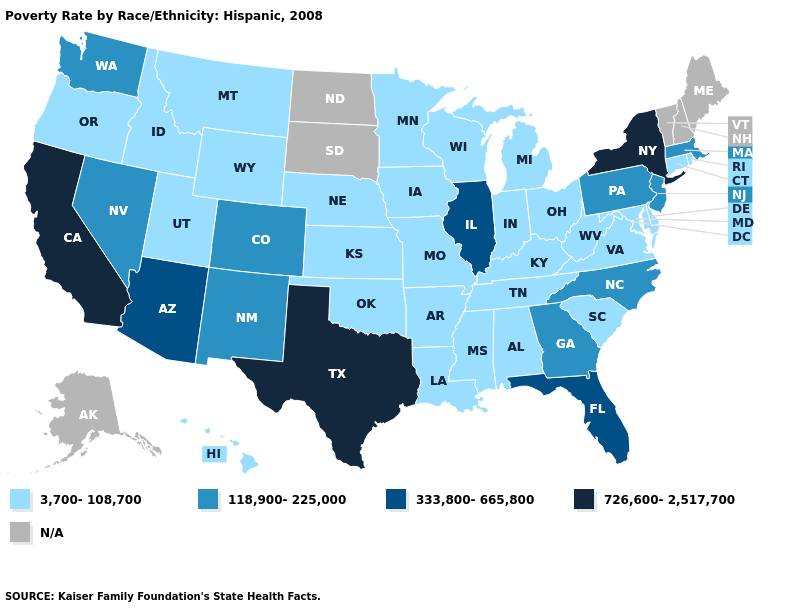Among the states that border Nevada , does Utah have the lowest value?
Be succinct. Yes. How many symbols are there in the legend?
Answer briefly. 5. Name the states that have a value in the range 726,600-2,517,700?
Answer briefly. California, New York, Texas. Name the states that have a value in the range 3,700-108,700?
Give a very brief answer. Alabama, Arkansas, Connecticut, Delaware, Hawaii, Idaho, Indiana, Iowa, Kansas, Kentucky, Louisiana, Maryland, Michigan, Minnesota, Mississippi, Missouri, Montana, Nebraska, Ohio, Oklahoma, Oregon, Rhode Island, South Carolina, Tennessee, Utah, Virginia, West Virginia, Wisconsin, Wyoming. Name the states that have a value in the range N/A?
Short answer required. Alaska, Maine, New Hampshire, North Dakota, South Dakota, Vermont. What is the value of Alabama?
Keep it brief. 3,700-108,700. What is the lowest value in the Northeast?
Short answer required. 3,700-108,700. What is the value of Alaska?
Short answer required. N/A. Which states have the lowest value in the Northeast?
Be succinct. Connecticut, Rhode Island. Name the states that have a value in the range N/A?
Short answer required. Alaska, Maine, New Hampshire, North Dakota, South Dakota, Vermont. What is the value of California?
Be succinct. 726,600-2,517,700. Which states have the lowest value in the USA?
Answer briefly. Alabama, Arkansas, Connecticut, Delaware, Hawaii, Idaho, Indiana, Iowa, Kansas, Kentucky, Louisiana, Maryland, Michigan, Minnesota, Mississippi, Missouri, Montana, Nebraska, Ohio, Oklahoma, Oregon, Rhode Island, South Carolina, Tennessee, Utah, Virginia, West Virginia, Wisconsin, Wyoming. Name the states that have a value in the range 726,600-2,517,700?
Be succinct. California, New York, Texas. Which states have the lowest value in the South?
Keep it brief. Alabama, Arkansas, Delaware, Kentucky, Louisiana, Maryland, Mississippi, Oklahoma, South Carolina, Tennessee, Virginia, West Virginia. Among the states that border Arizona , which have the lowest value?
Give a very brief answer. Utah. 